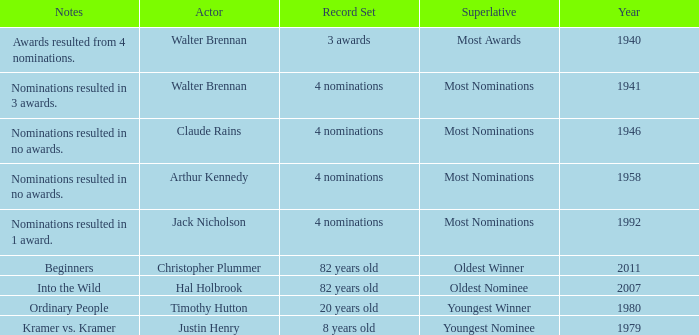What is the earliest year for ordinary people to appear in the notes? 1980.0. 